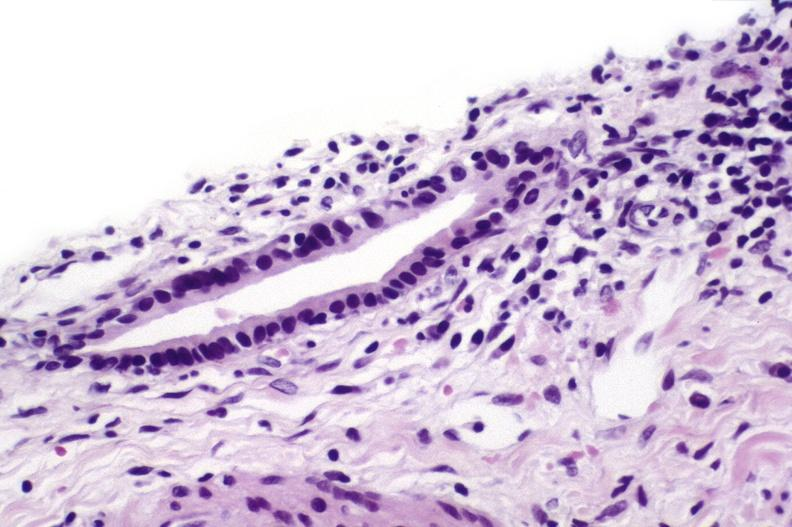what is present?
Answer the question using a single word or phrase. Liver 